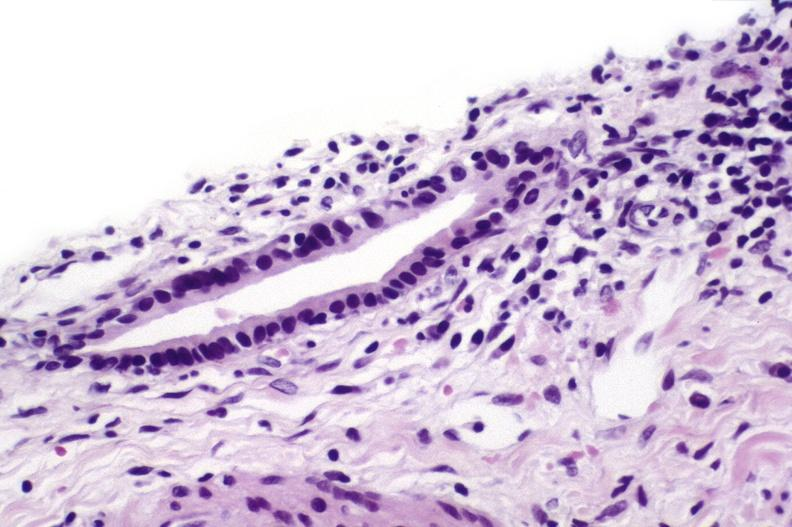what is present?
Answer the question using a single word or phrase. Liver 